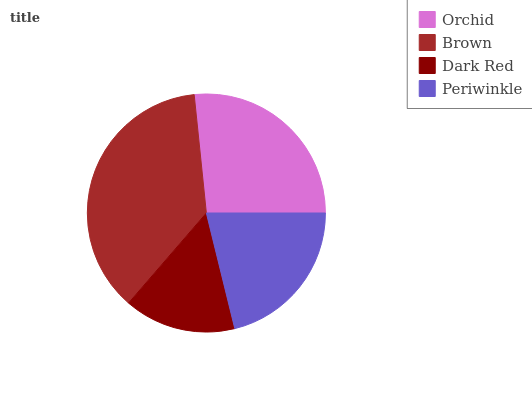Is Dark Red the minimum?
Answer yes or no. Yes. Is Brown the maximum?
Answer yes or no. Yes. Is Brown the minimum?
Answer yes or no. No. Is Dark Red the maximum?
Answer yes or no. No. Is Brown greater than Dark Red?
Answer yes or no. Yes. Is Dark Red less than Brown?
Answer yes or no. Yes. Is Dark Red greater than Brown?
Answer yes or no. No. Is Brown less than Dark Red?
Answer yes or no. No. Is Orchid the high median?
Answer yes or no. Yes. Is Periwinkle the low median?
Answer yes or no. Yes. Is Periwinkle the high median?
Answer yes or no. No. Is Brown the low median?
Answer yes or no. No. 